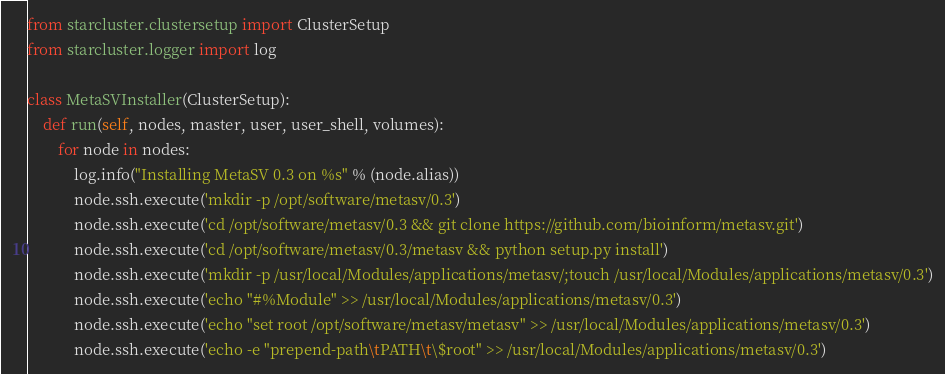<code> <loc_0><loc_0><loc_500><loc_500><_Python_>from starcluster.clustersetup import ClusterSetup
from starcluster.logger import log

class MetaSVInstaller(ClusterSetup):
	def run(self, nodes, master, user, user_shell, volumes):
		for node in nodes:
			log.info("Installing MetaSV 0.3 on %s" % (node.alias))
			node.ssh.execute('mkdir -p /opt/software/metasv/0.3')
			node.ssh.execute('cd /opt/software/metasv/0.3 && git clone https://github.com/bioinform/metasv.git')
			node.ssh.execute('cd /opt/software/metasv/0.3/metasv && python setup.py install') 
			node.ssh.execute('mkdir -p /usr/local/Modules/applications/metasv/;touch /usr/local/Modules/applications/metasv/0.3')
			node.ssh.execute('echo "#%Module" >> /usr/local/Modules/applications/metasv/0.3')
			node.ssh.execute('echo "set root /opt/software/metasv/metasv" >> /usr/local/Modules/applications/metasv/0.3')
			node.ssh.execute('echo -e "prepend-path\tPATH\t\$root" >> /usr/local/Modules/applications/metasv/0.3')
</code> 